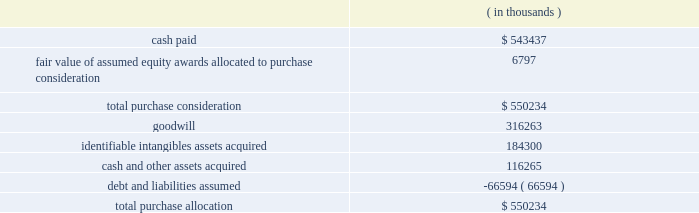Synopsys , inc .
Notes to consolidated financial statements 2014continued acquisition of magma design automation , inc .
( magma ) on february 22 , 2012 , the company acquired all outstanding shares of magma , a chip design software provider , at a per-share price of $ 7.35 .
Additionally , the company assumed unvested restricted stock units ( rsus ) and stock options , collectively called 201cequity awards . 201d the aggregate purchase price was approximately $ 550.2 million .
This acquisition enables the company to more rapidly meet the needs of leading-edge semiconductor designers for more sophisticated design tools .
As of october 31 , 2012 , the total purchase consideration and the preliminary purchase price allocation were as follows: .
Goodwill of $ 316.3 million , which is not deductible for tax purposes , primarily resulted from the company 2019s expectation of sales growth and cost synergies from the integration of magma 2019s technology and operations with the company 2019s technology and operations .
Identifiable intangible assets , consisting primarily of technology , customer relationships , backlog and trademarks , were valued using the income method , and are being amortized over three to ten years .
Acquisition-related costs directly attributable to the business combination totaling $ 33.5 million for fiscal 2012 were expensed as incurred in the consolidated statements of operations and consist primarily of employee separation costs , contract terminations , professional services , and facilities closure costs .
Fair value of equity awards assumed .
The company assumed unvested restricted stock units ( rsus ) and stock options with a fair value of $ 22.2 million .
The black-scholes option-pricing model was used to determine the fair value of these stock options , whereas the fair value of the rsus was based on the market price on the grant date of the instruments .
The black-scholes option-pricing model incorporates various subjective assumptions including expected volatility , expected term and risk-free interest rates .
The expected volatility was estimated by a combination of implied and historical stock price volatility of the options .
Of the total fair value of the equity awards assumed , $ 6.8 million was allocated to the purchase consideration and $ 15.4 million was allocated to future services to be expensed over their remaining service periods on a straight-line basis .
Supplemental pro forma information ( unaudited ) .
The financial information in the table below summarizes the combined results of operations of the company and magma , on a pro forma basis , as though the companies had been combined as of the beginning of fiscal 2011. .
What percentage of the total purchase consideration was for intangible assets? 
Rationale: good will is also an intangible asset and thus need to be combined with the identifiable intangibles to arrive at the non hard assets percentage of the price .
Computations: ((316263 + 184300) / 550234)
Answer: 0.90973. 